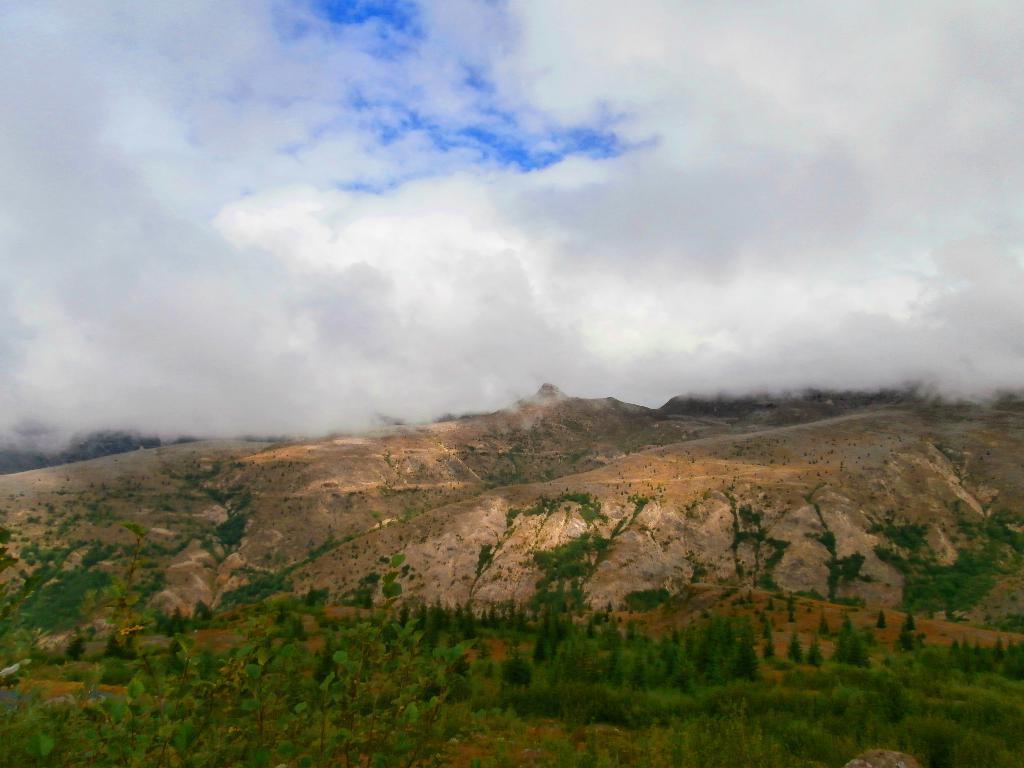Could you give a brief overview of what you see in this image? This is an outside view. At the bottom there are many trees and rocks. At the top of the image I can see the sky and clouds. 